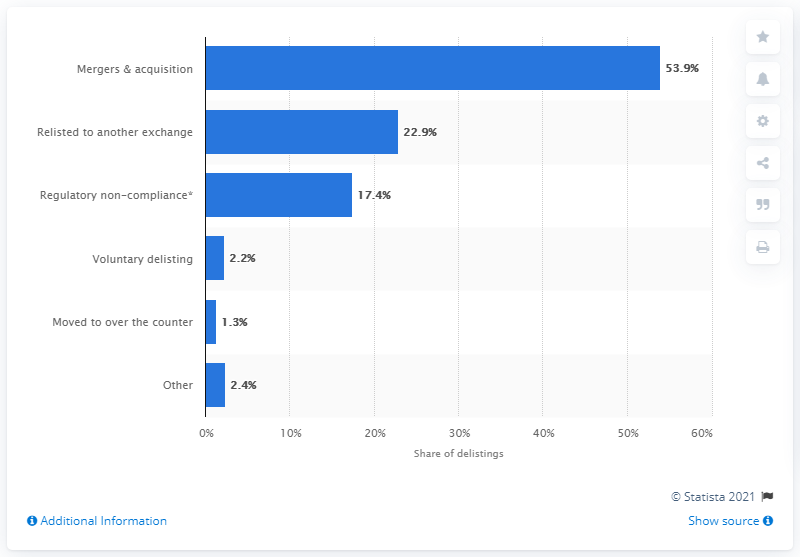Mention a couple of crucial points in this snapshot. During the period of 1999 to 2013, approximately 17.4% of delistings were caused by regulatory non-compliance. 